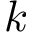<formula> <loc_0><loc_0><loc_500><loc_500>k</formula> 